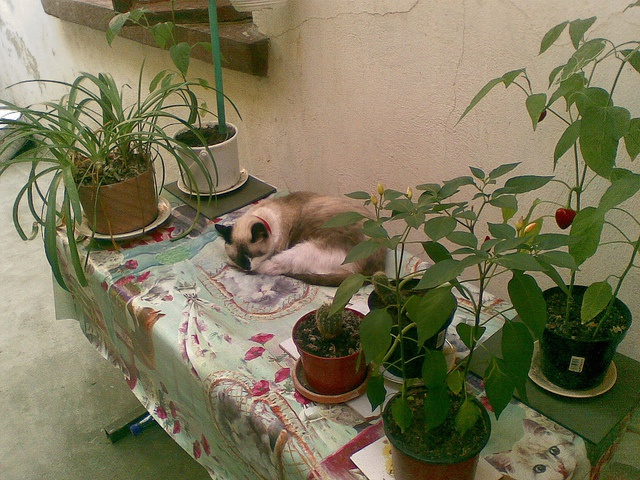Describe the objects in this image and their specific colors. I can see potted plant in ivory, darkgreen, and tan tones, potted plant in ivory, darkgreen, gray, black, and tan tones, potted plant in ivory, darkgreen, gray, and tan tones, potted plant in ivory, darkgreen, tan, and gray tones, and cat in ivory, gray, tan, and black tones in this image. 